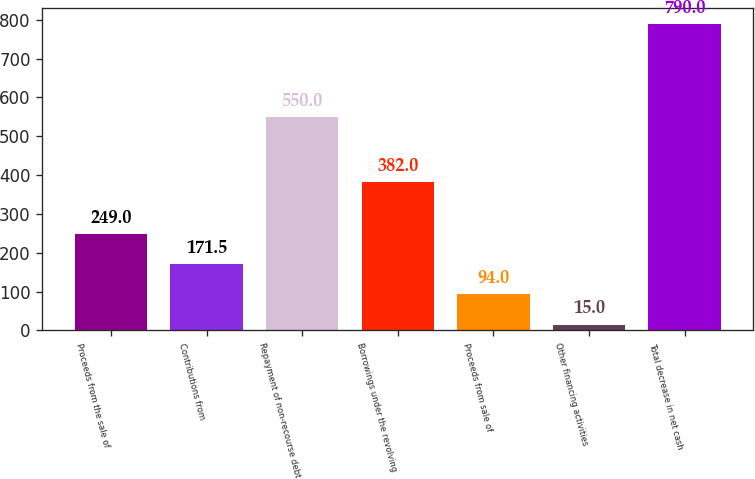<chart> <loc_0><loc_0><loc_500><loc_500><bar_chart><fcel>Proceeds from the sale of<fcel>Contributions from<fcel>Repayment of non-recourse debt<fcel>Borrowings under the revolving<fcel>Proceeds from sale of<fcel>Other financing activities<fcel>Total decrease in net cash<nl><fcel>249<fcel>171.5<fcel>550<fcel>382<fcel>94<fcel>15<fcel>790<nl></chart> 